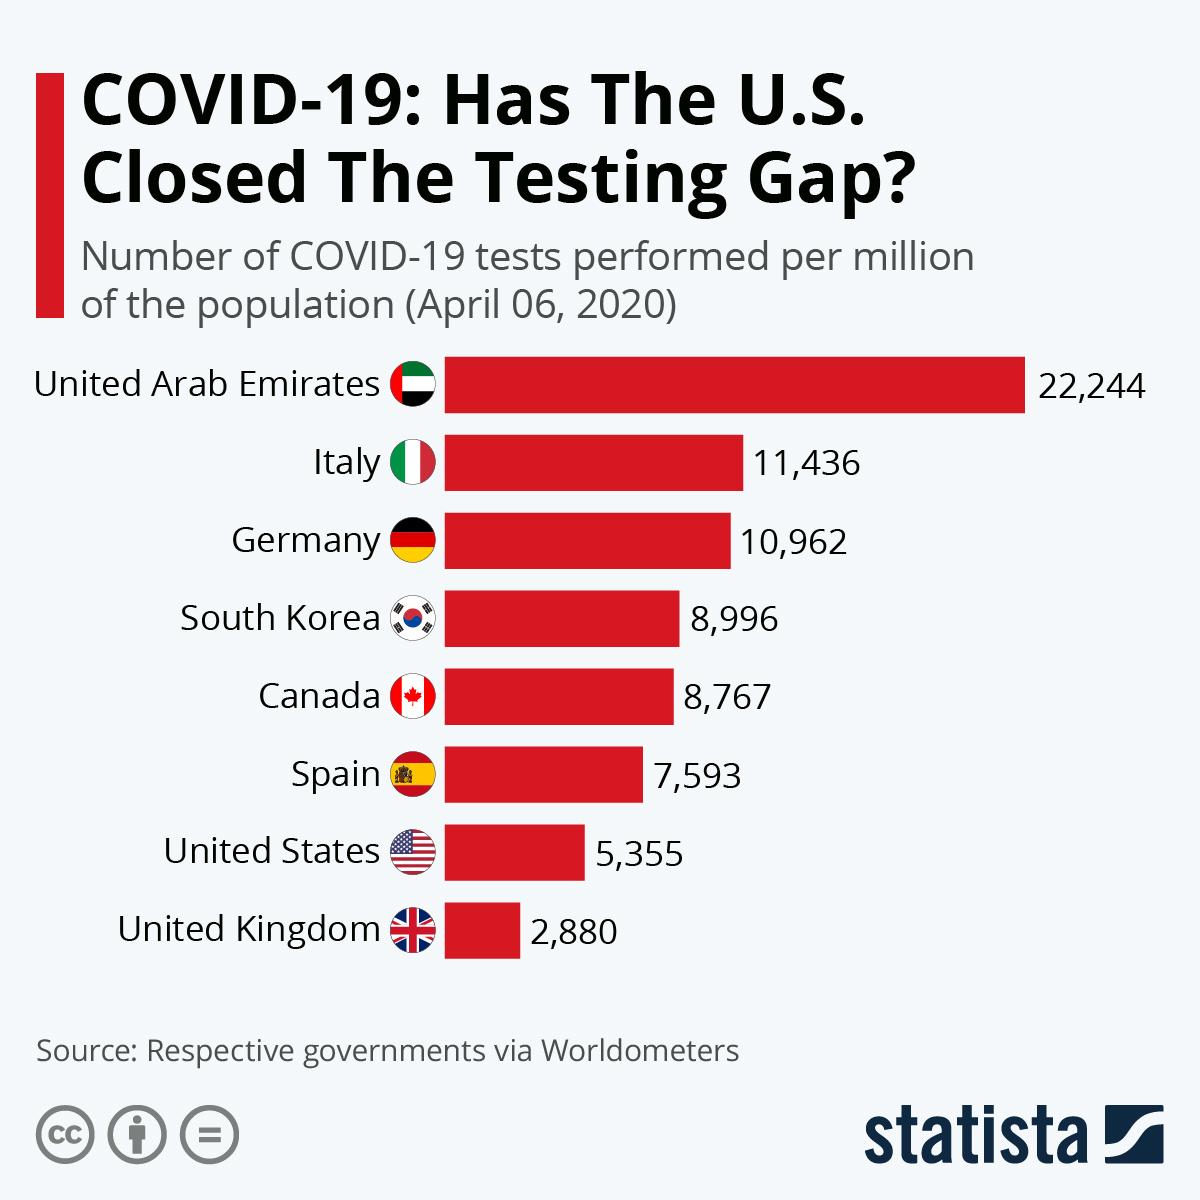List a handful of essential elements in this visual. The second-most COVID-19 tests per million population were conducted in Italy among the selected countries as of April 06, 2020. The United Kingdom has performed the least number of COVID-19 tests per million population among the selected countries as of April 06, 2020, according to our analysis. The United States has performed the second-lowest number of COVID-19 tests per million population among the selected countries as of April 06, 2020. The United Arab Emirates has performed the highest number of COVID-19 tests per million population among the selected countries as of April 06, 2020. As of April 06, 2020, Germany had performed 10,962 COVID-19 tests per million of its population. 